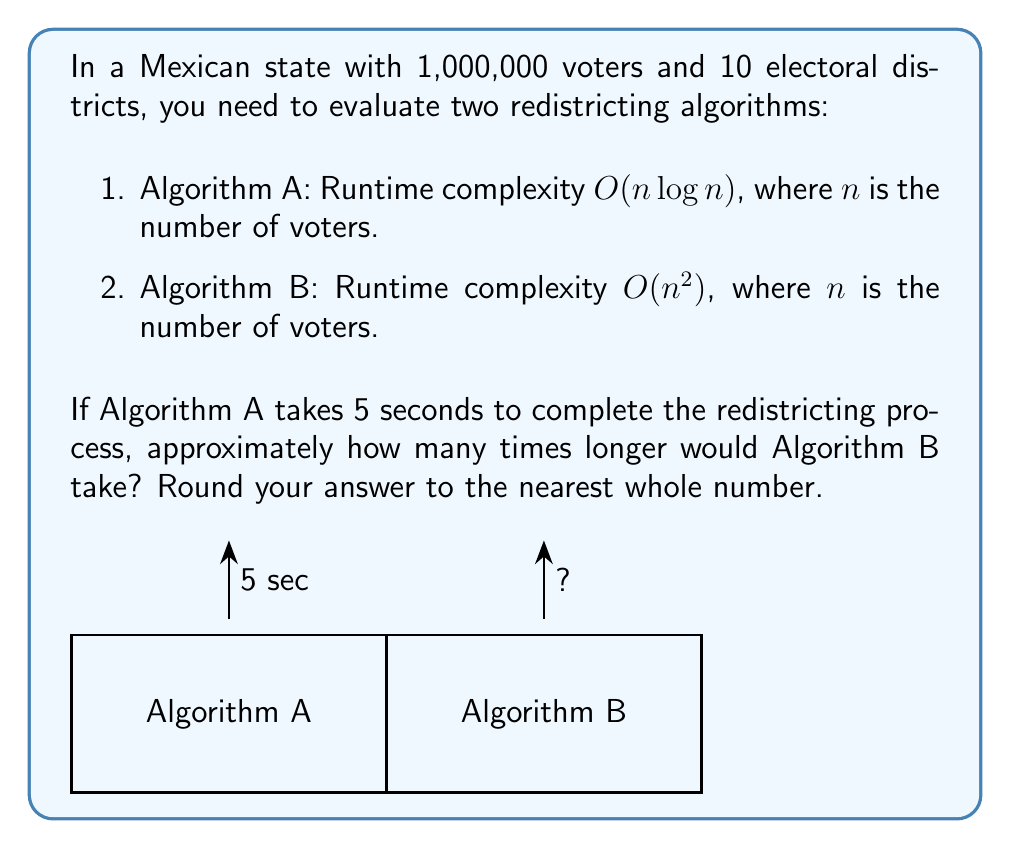What is the answer to this math problem? Let's approach this step-by-step:

1) First, we need to understand the runtime complexities:
   - Algorithm A: $O(n \log n)$
   - Algorithm B: $O(n^2)$

2) We're told that Algorithm A takes 5 seconds for $n = 1,000,000$ voters.

3) To compare the algorithms, we need to calculate the ratio of their runtimes:

   $$\frac{\text{Runtime of B}}{\text{Runtime of A}} = \frac{n^2}{n \log n} = \frac{n}{\log n}$$

4) Let's substitute $n = 1,000,000$:

   $$\frac{1,000,000}{\log 1,000,000} \approx \frac{1,000,000}{20} = 50,000$$

5) This means Algorithm B will take approximately 50,000 times longer than Algorithm A.

6) If Algorithm A takes 5 seconds, then Algorithm B will take:

   $$5 \text{ seconds} \times 50,000 = 250,000 \text{ seconds}$$

7) To express this in terms of "how many times longer," we divide by the original time:

   $$\frac{250,000 \text{ seconds}}{5 \text{ seconds}} = 50,000 \text{ times longer}$$

Thus, Algorithm B would take approximately 50,000 times longer than Algorithm A.
Answer: 50,000 times 